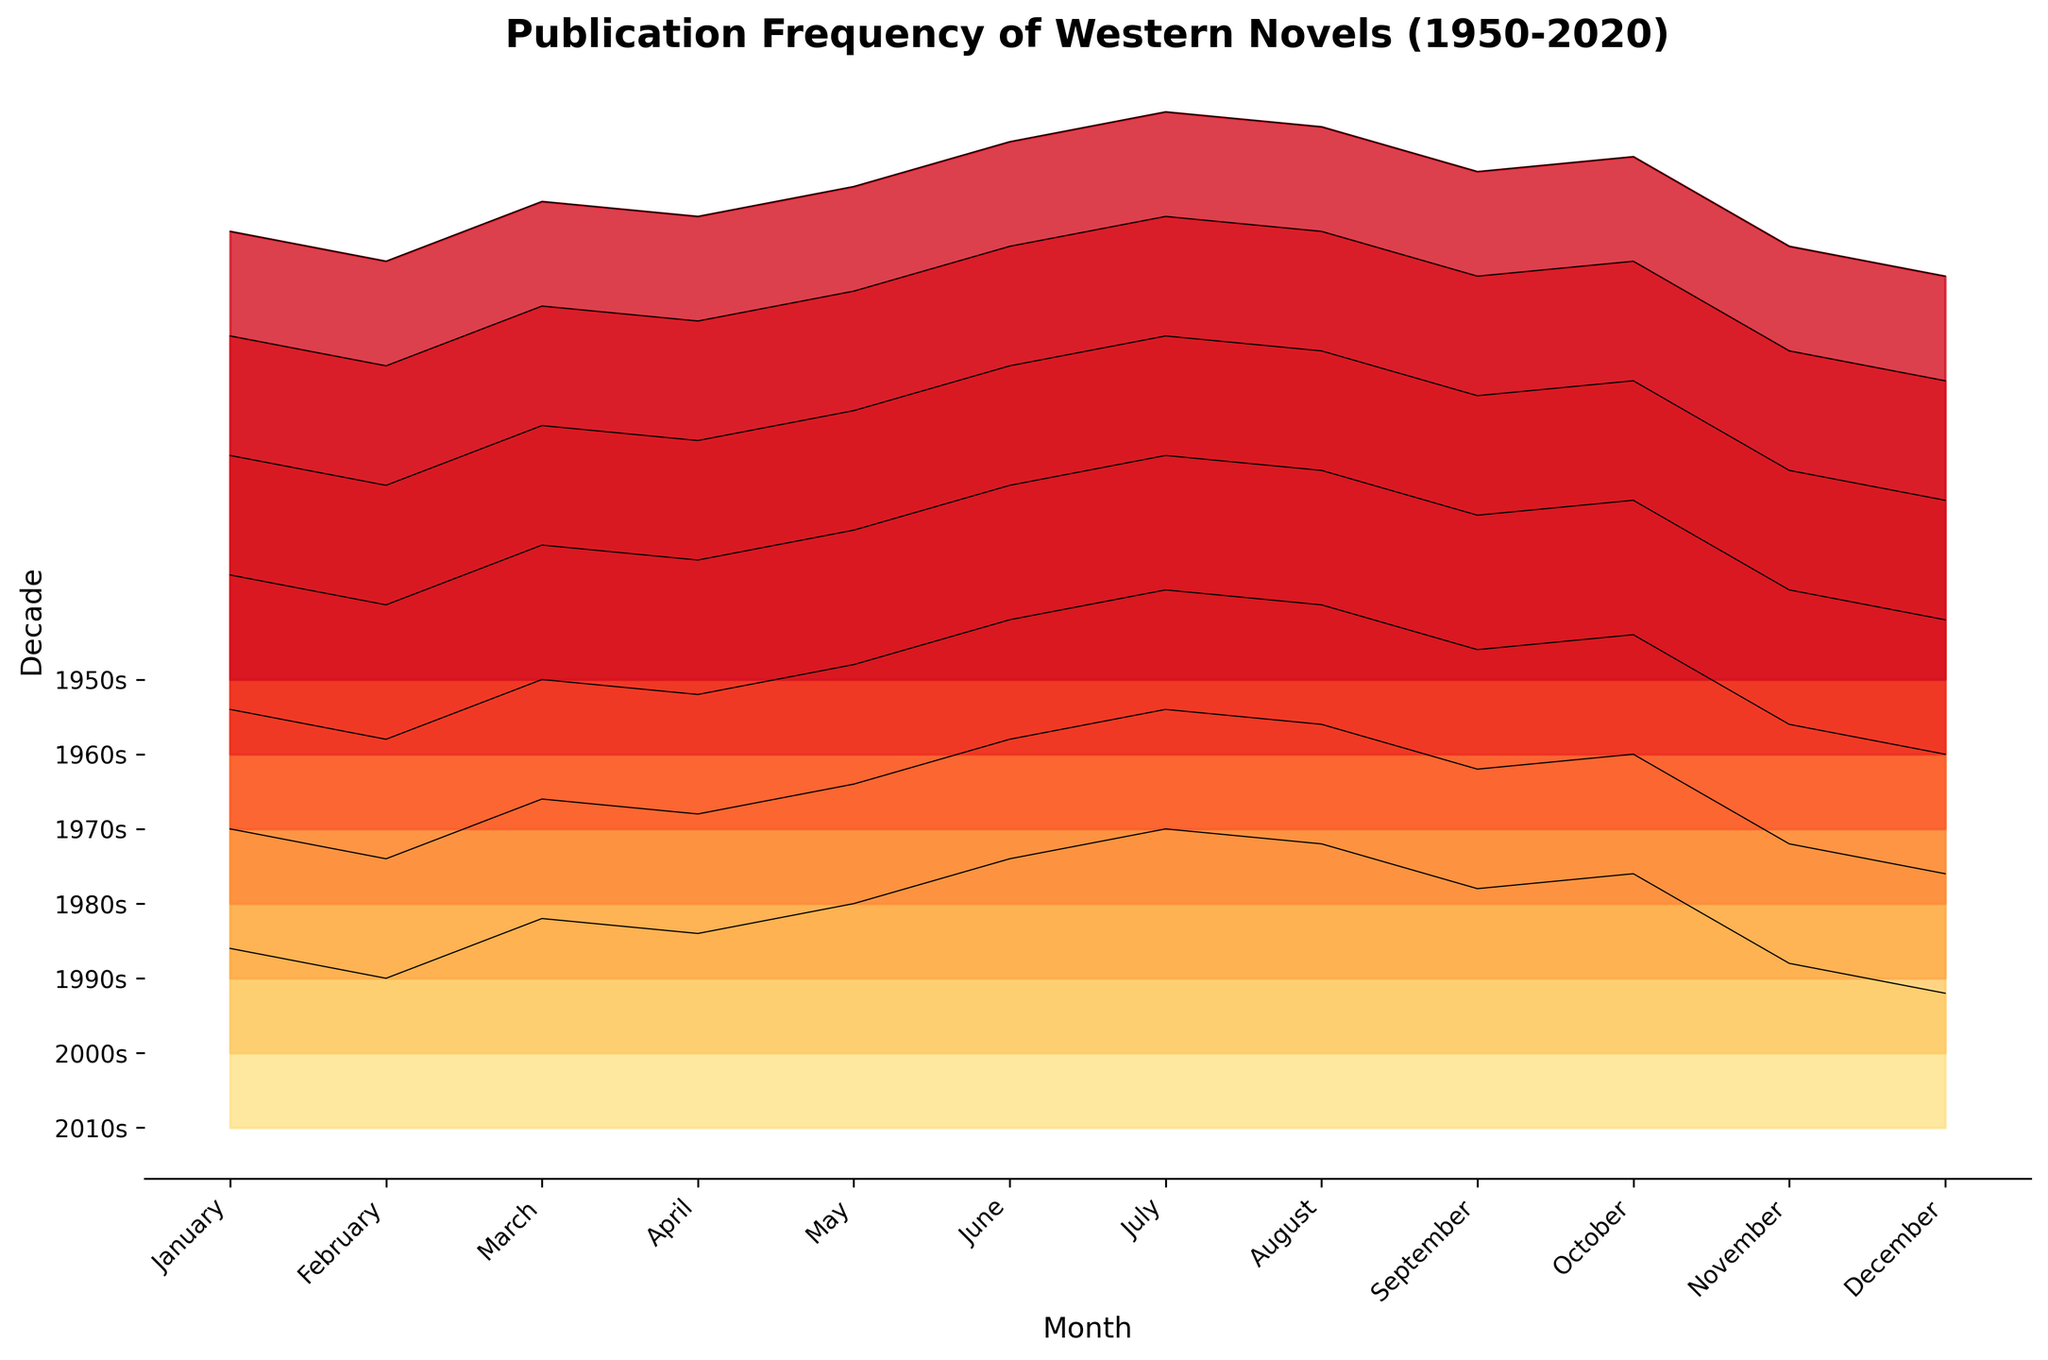What's the title of the figure? The title of a figure is usually located at the top center. Here, it reads "Publication Frequency of Western Novels (1950-2020)".
Answer: Publication Frequency of Western Novels (1950-2020) Which month had the highest publication frequency in the 2000s? Let's identify the highest peak of the 2000s line among all months. The tallest peak in the 2000s is in July.
Answer: July In which decade did June see a publication frequency of 24? Locate the month June on the x-axis, then find where the value 24 aligns in relation to the ridgelines of each decade. This value is in the 1970s.
Answer: 1970s How does the publication frequency in January change from the 1950s to 2010s? We need to compare the values for January from each decade's ridgeline. In the 1950s the value is 12, and it progressively increases to 30 in the 2010s.
Answer: Increases from 12 to 30 Which month shows the least variation in publication frequency across decades? Observing the ridgelines, December has a relatively consistent upward trend without significant gaps between decades compared to other months.
Answer: December Between which decades does August see the highest increase in publication frequency? Reviewing the data from August over the decades, the largest jump is from the 1950s (19) to the 2000s (35), which is a difference of 16. Other decades have smaller changes.
Answer: 1950s to 2000s What is the difference in publication frequency between March and November in the 1990s? Locate March and November on the x-axis and check their 1990s values: March has 27 and November has 24. The difference is 27 - 24.
Answer: 3 When did July first exceed 30 publications? Trace the value of 30 along the ridgelines for July. July first exceeds 30 publications in the 1990s.
Answer: 1990s Which decade has the most diverse range of publication frequencies? Observe each decade's range in publication frequencies. The 2010s show the highest range from 27 (December) to 38 (July).
Answer: 2010s 